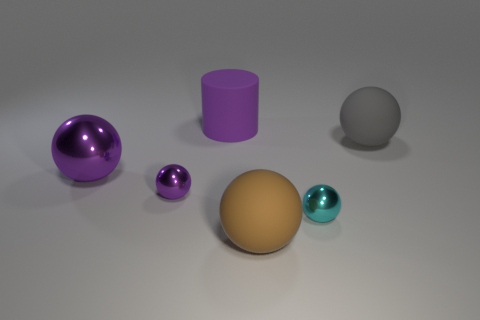What is the color of the metal sphere that is the same size as the brown matte ball?
Make the answer very short. Purple. Does the small sphere that is on the left side of the tiny cyan shiny ball have the same material as the cyan ball?
Offer a very short reply. Yes. There is a tiny shiny object that is to the left of the small shiny ball on the right side of the brown object; are there any purple matte things behind it?
Provide a succinct answer. Yes. Is the shape of the purple object behind the gray thing the same as  the big brown rubber thing?
Offer a very short reply. No. What shape is the rubber thing on the right side of the tiny ball that is right of the small purple metal ball?
Provide a short and direct response. Sphere. What is the size of the purple ball that is left of the tiny metallic sphere that is behind the metal thing that is to the right of the brown object?
Give a very brief answer. Large. There is a big shiny thing that is the same shape as the small purple shiny object; what color is it?
Make the answer very short. Purple. Do the gray rubber sphere and the purple cylinder have the same size?
Your answer should be compact. Yes. There is a big thing right of the large brown rubber sphere; what is it made of?
Keep it short and to the point. Rubber. What number of other objects are there of the same shape as the small cyan metallic thing?
Your answer should be very brief. 4. 